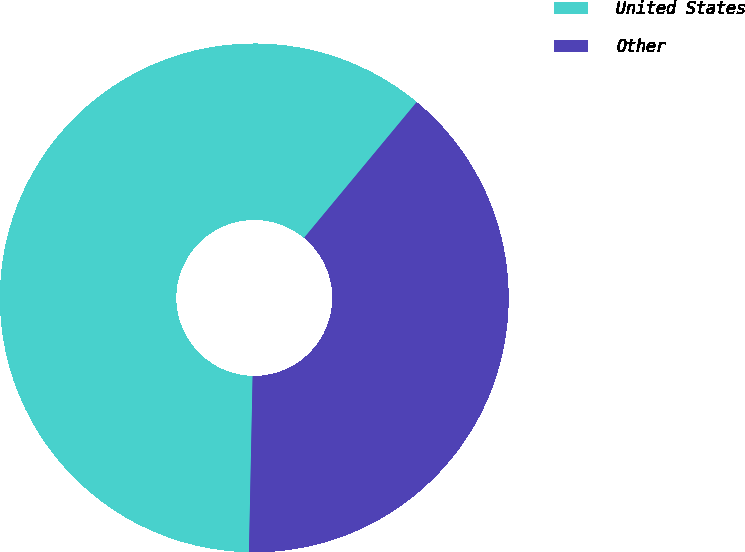Convert chart. <chart><loc_0><loc_0><loc_500><loc_500><pie_chart><fcel>United States<fcel>Other<nl><fcel>60.69%<fcel>39.31%<nl></chart> 